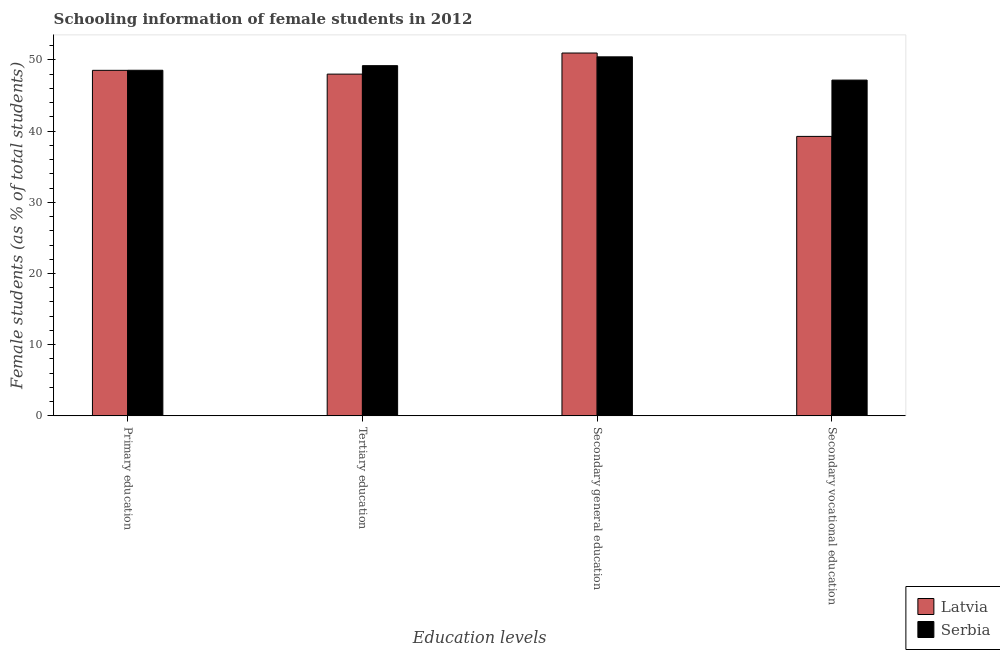How many groups of bars are there?
Make the answer very short. 4. Are the number of bars per tick equal to the number of legend labels?
Provide a short and direct response. Yes. How many bars are there on the 3rd tick from the left?
Your response must be concise. 2. What is the label of the 3rd group of bars from the left?
Your answer should be compact. Secondary general education. What is the percentage of female students in tertiary education in Latvia?
Your answer should be compact. 48.01. Across all countries, what is the maximum percentage of female students in secondary vocational education?
Offer a very short reply. 47.17. Across all countries, what is the minimum percentage of female students in primary education?
Your answer should be compact. 48.54. In which country was the percentage of female students in tertiary education maximum?
Make the answer very short. Serbia. In which country was the percentage of female students in secondary vocational education minimum?
Make the answer very short. Latvia. What is the total percentage of female students in tertiary education in the graph?
Ensure brevity in your answer.  97.2. What is the difference between the percentage of female students in secondary education in Serbia and that in Latvia?
Keep it short and to the point. -0.54. What is the difference between the percentage of female students in tertiary education in Latvia and the percentage of female students in primary education in Serbia?
Your response must be concise. -0.54. What is the average percentage of female students in primary education per country?
Provide a succinct answer. 48.54. What is the difference between the percentage of female students in secondary education and percentage of female students in secondary vocational education in Latvia?
Ensure brevity in your answer.  11.71. What is the ratio of the percentage of female students in secondary education in Serbia to that in Latvia?
Your answer should be compact. 0.99. Is the difference between the percentage of female students in secondary vocational education in Latvia and Serbia greater than the difference between the percentage of female students in primary education in Latvia and Serbia?
Make the answer very short. No. What is the difference between the highest and the second highest percentage of female students in secondary education?
Offer a very short reply. 0.54. What is the difference between the highest and the lowest percentage of female students in primary education?
Make the answer very short. 0.01. What does the 2nd bar from the left in Tertiary education represents?
Give a very brief answer. Serbia. What does the 2nd bar from the right in Secondary vocational education represents?
Keep it short and to the point. Latvia. Is it the case that in every country, the sum of the percentage of female students in primary education and percentage of female students in tertiary education is greater than the percentage of female students in secondary education?
Your response must be concise. Yes. Are the values on the major ticks of Y-axis written in scientific E-notation?
Give a very brief answer. No. Does the graph contain grids?
Ensure brevity in your answer.  No. How many legend labels are there?
Ensure brevity in your answer.  2. What is the title of the graph?
Ensure brevity in your answer.  Schooling information of female students in 2012. Does "Ethiopia" appear as one of the legend labels in the graph?
Offer a terse response. No. What is the label or title of the X-axis?
Your answer should be very brief. Education levels. What is the label or title of the Y-axis?
Offer a terse response. Female students (as % of total students). What is the Female students (as % of total students) in Latvia in Primary education?
Provide a short and direct response. 48.54. What is the Female students (as % of total students) of Serbia in Primary education?
Your answer should be compact. 48.55. What is the Female students (as % of total students) of Latvia in Tertiary education?
Ensure brevity in your answer.  48.01. What is the Female students (as % of total students) in Serbia in Tertiary education?
Ensure brevity in your answer.  49.19. What is the Female students (as % of total students) in Latvia in Secondary general education?
Offer a terse response. 50.97. What is the Female students (as % of total students) of Serbia in Secondary general education?
Keep it short and to the point. 50.43. What is the Female students (as % of total students) of Latvia in Secondary vocational education?
Your answer should be very brief. 39.26. What is the Female students (as % of total students) in Serbia in Secondary vocational education?
Keep it short and to the point. 47.17. Across all Education levels, what is the maximum Female students (as % of total students) of Latvia?
Offer a very short reply. 50.97. Across all Education levels, what is the maximum Female students (as % of total students) of Serbia?
Provide a short and direct response. 50.43. Across all Education levels, what is the minimum Female students (as % of total students) in Latvia?
Provide a short and direct response. 39.26. Across all Education levels, what is the minimum Female students (as % of total students) of Serbia?
Give a very brief answer. 47.17. What is the total Female students (as % of total students) in Latvia in the graph?
Keep it short and to the point. 186.77. What is the total Female students (as % of total students) in Serbia in the graph?
Make the answer very short. 195.34. What is the difference between the Female students (as % of total students) in Latvia in Primary education and that in Tertiary education?
Keep it short and to the point. 0.53. What is the difference between the Female students (as % of total students) in Serbia in Primary education and that in Tertiary education?
Ensure brevity in your answer.  -0.65. What is the difference between the Female students (as % of total students) in Latvia in Primary education and that in Secondary general education?
Your answer should be very brief. -2.43. What is the difference between the Female students (as % of total students) of Serbia in Primary education and that in Secondary general education?
Ensure brevity in your answer.  -1.89. What is the difference between the Female students (as % of total students) in Latvia in Primary education and that in Secondary vocational education?
Your response must be concise. 9.28. What is the difference between the Female students (as % of total students) in Serbia in Primary education and that in Secondary vocational education?
Make the answer very short. 1.38. What is the difference between the Female students (as % of total students) of Latvia in Tertiary education and that in Secondary general education?
Your answer should be very brief. -2.96. What is the difference between the Female students (as % of total students) of Serbia in Tertiary education and that in Secondary general education?
Make the answer very short. -1.24. What is the difference between the Female students (as % of total students) of Latvia in Tertiary education and that in Secondary vocational education?
Offer a very short reply. 8.75. What is the difference between the Female students (as % of total students) in Serbia in Tertiary education and that in Secondary vocational education?
Offer a terse response. 2.03. What is the difference between the Female students (as % of total students) in Latvia in Secondary general education and that in Secondary vocational education?
Keep it short and to the point. 11.71. What is the difference between the Female students (as % of total students) of Serbia in Secondary general education and that in Secondary vocational education?
Your answer should be compact. 3.27. What is the difference between the Female students (as % of total students) in Latvia in Primary education and the Female students (as % of total students) in Serbia in Tertiary education?
Ensure brevity in your answer.  -0.66. What is the difference between the Female students (as % of total students) of Latvia in Primary education and the Female students (as % of total students) of Serbia in Secondary general education?
Offer a terse response. -1.9. What is the difference between the Female students (as % of total students) in Latvia in Primary education and the Female students (as % of total students) in Serbia in Secondary vocational education?
Your response must be concise. 1.37. What is the difference between the Female students (as % of total students) of Latvia in Tertiary education and the Female students (as % of total students) of Serbia in Secondary general education?
Offer a very short reply. -2.43. What is the difference between the Female students (as % of total students) of Latvia in Tertiary education and the Female students (as % of total students) of Serbia in Secondary vocational education?
Keep it short and to the point. 0.84. What is the difference between the Female students (as % of total students) in Latvia in Secondary general education and the Female students (as % of total students) in Serbia in Secondary vocational education?
Provide a succinct answer. 3.8. What is the average Female students (as % of total students) in Latvia per Education levels?
Offer a terse response. 46.69. What is the average Female students (as % of total students) of Serbia per Education levels?
Give a very brief answer. 48.83. What is the difference between the Female students (as % of total students) of Latvia and Female students (as % of total students) of Serbia in Primary education?
Your answer should be very brief. -0.01. What is the difference between the Female students (as % of total students) of Latvia and Female students (as % of total students) of Serbia in Tertiary education?
Provide a succinct answer. -1.19. What is the difference between the Female students (as % of total students) of Latvia and Female students (as % of total students) of Serbia in Secondary general education?
Offer a terse response. 0.54. What is the difference between the Female students (as % of total students) in Latvia and Female students (as % of total students) in Serbia in Secondary vocational education?
Your response must be concise. -7.91. What is the ratio of the Female students (as % of total students) in Latvia in Primary education to that in Tertiary education?
Offer a terse response. 1.01. What is the ratio of the Female students (as % of total students) of Serbia in Primary education to that in Tertiary education?
Your answer should be compact. 0.99. What is the ratio of the Female students (as % of total students) in Latvia in Primary education to that in Secondary general education?
Your response must be concise. 0.95. What is the ratio of the Female students (as % of total students) in Serbia in Primary education to that in Secondary general education?
Your answer should be compact. 0.96. What is the ratio of the Female students (as % of total students) in Latvia in Primary education to that in Secondary vocational education?
Your answer should be very brief. 1.24. What is the ratio of the Female students (as % of total students) in Serbia in Primary education to that in Secondary vocational education?
Keep it short and to the point. 1.03. What is the ratio of the Female students (as % of total students) in Latvia in Tertiary education to that in Secondary general education?
Your response must be concise. 0.94. What is the ratio of the Female students (as % of total students) in Serbia in Tertiary education to that in Secondary general education?
Provide a short and direct response. 0.98. What is the ratio of the Female students (as % of total students) of Latvia in Tertiary education to that in Secondary vocational education?
Provide a short and direct response. 1.22. What is the ratio of the Female students (as % of total students) in Serbia in Tertiary education to that in Secondary vocational education?
Your answer should be compact. 1.04. What is the ratio of the Female students (as % of total students) of Latvia in Secondary general education to that in Secondary vocational education?
Ensure brevity in your answer.  1.3. What is the ratio of the Female students (as % of total students) of Serbia in Secondary general education to that in Secondary vocational education?
Your answer should be very brief. 1.07. What is the difference between the highest and the second highest Female students (as % of total students) in Latvia?
Offer a terse response. 2.43. What is the difference between the highest and the second highest Female students (as % of total students) in Serbia?
Offer a terse response. 1.24. What is the difference between the highest and the lowest Female students (as % of total students) of Latvia?
Make the answer very short. 11.71. What is the difference between the highest and the lowest Female students (as % of total students) of Serbia?
Make the answer very short. 3.27. 